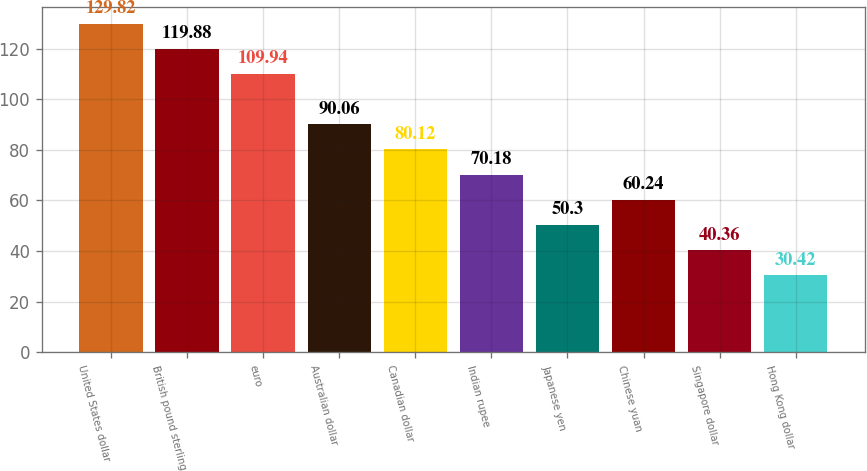Convert chart. <chart><loc_0><loc_0><loc_500><loc_500><bar_chart><fcel>United States dollar<fcel>British pound sterling<fcel>euro<fcel>Australian dollar<fcel>Canadian dollar<fcel>Indian rupee<fcel>Japanese yen<fcel>Chinese yuan<fcel>Singapore dollar<fcel>Hong Kong dollar<nl><fcel>129.82<fcel>119.88<fcel>109.94<fcel>90.06<fcel>80.12<fcel>70.18<fcel>50.3<fcel>60.24<fcel>40.36<fcel>30.42<nl></chart> 